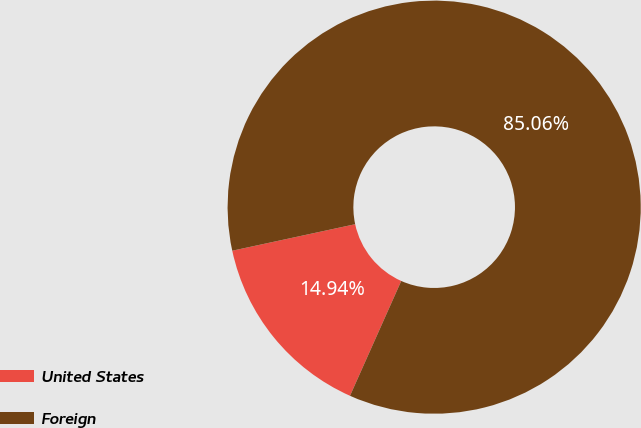Convert chart to OTSL. <chart><loc_0><loc_0><loc_500><loc_500><pie_chart><fcel>United States<fcel>Foreign<nl><fcel>14.94%<fcel>85.06%<nl></chart> 